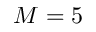<formula> <loc_0><loc_0><loc_500><loc_500>M = 5</formula> 